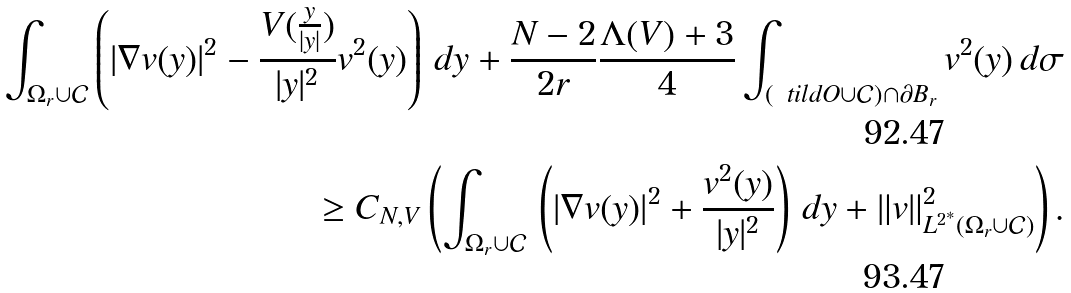<formula> <loc_0><loc_0><loc_500><loc_500>\int _ { \Omega _ { r } \cup \mathcal { C } } \left ( | \nabla v ( y ) | ^ { 2 } - \frac { V ( \frac { y } { | y | } ) } { | y | ^ { 2 } } v ^ { 2 } ( y ) \right ) \, d y + \frac { N - 2 } { 2 r } \frac { \Lambda ( V ) + 3 } 4 \int _ { ( \ t i l d O \cup \mathcal { C } ) \cap \partial B _ { r } } v ^ { 2 } ( y ) \, d \sigma \\ \geq C _ { N , V } \left ( \int _ { \Omega _ { r } \cup \mathcal { C } } \, \left ( | \nabla v ( y ) | ^ { 2 } + \frac { v ^ { 2 } ( y ) } { | y | ^ { 2 } } \right ) \, d y + \| v \| _ { L ^ { 2 ^ { * } } ( \Omega _ { r } \cup \mathcal { C } ) } ^ { 2 } \right ) .</formula> 